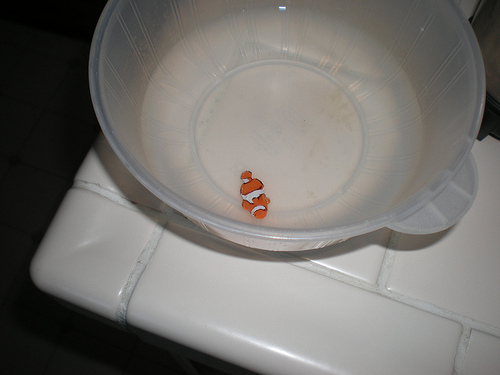<image>
Is there a fish in the bowl? Yes. The fish is contained within or inside the bowl, showing a containment relationship. 